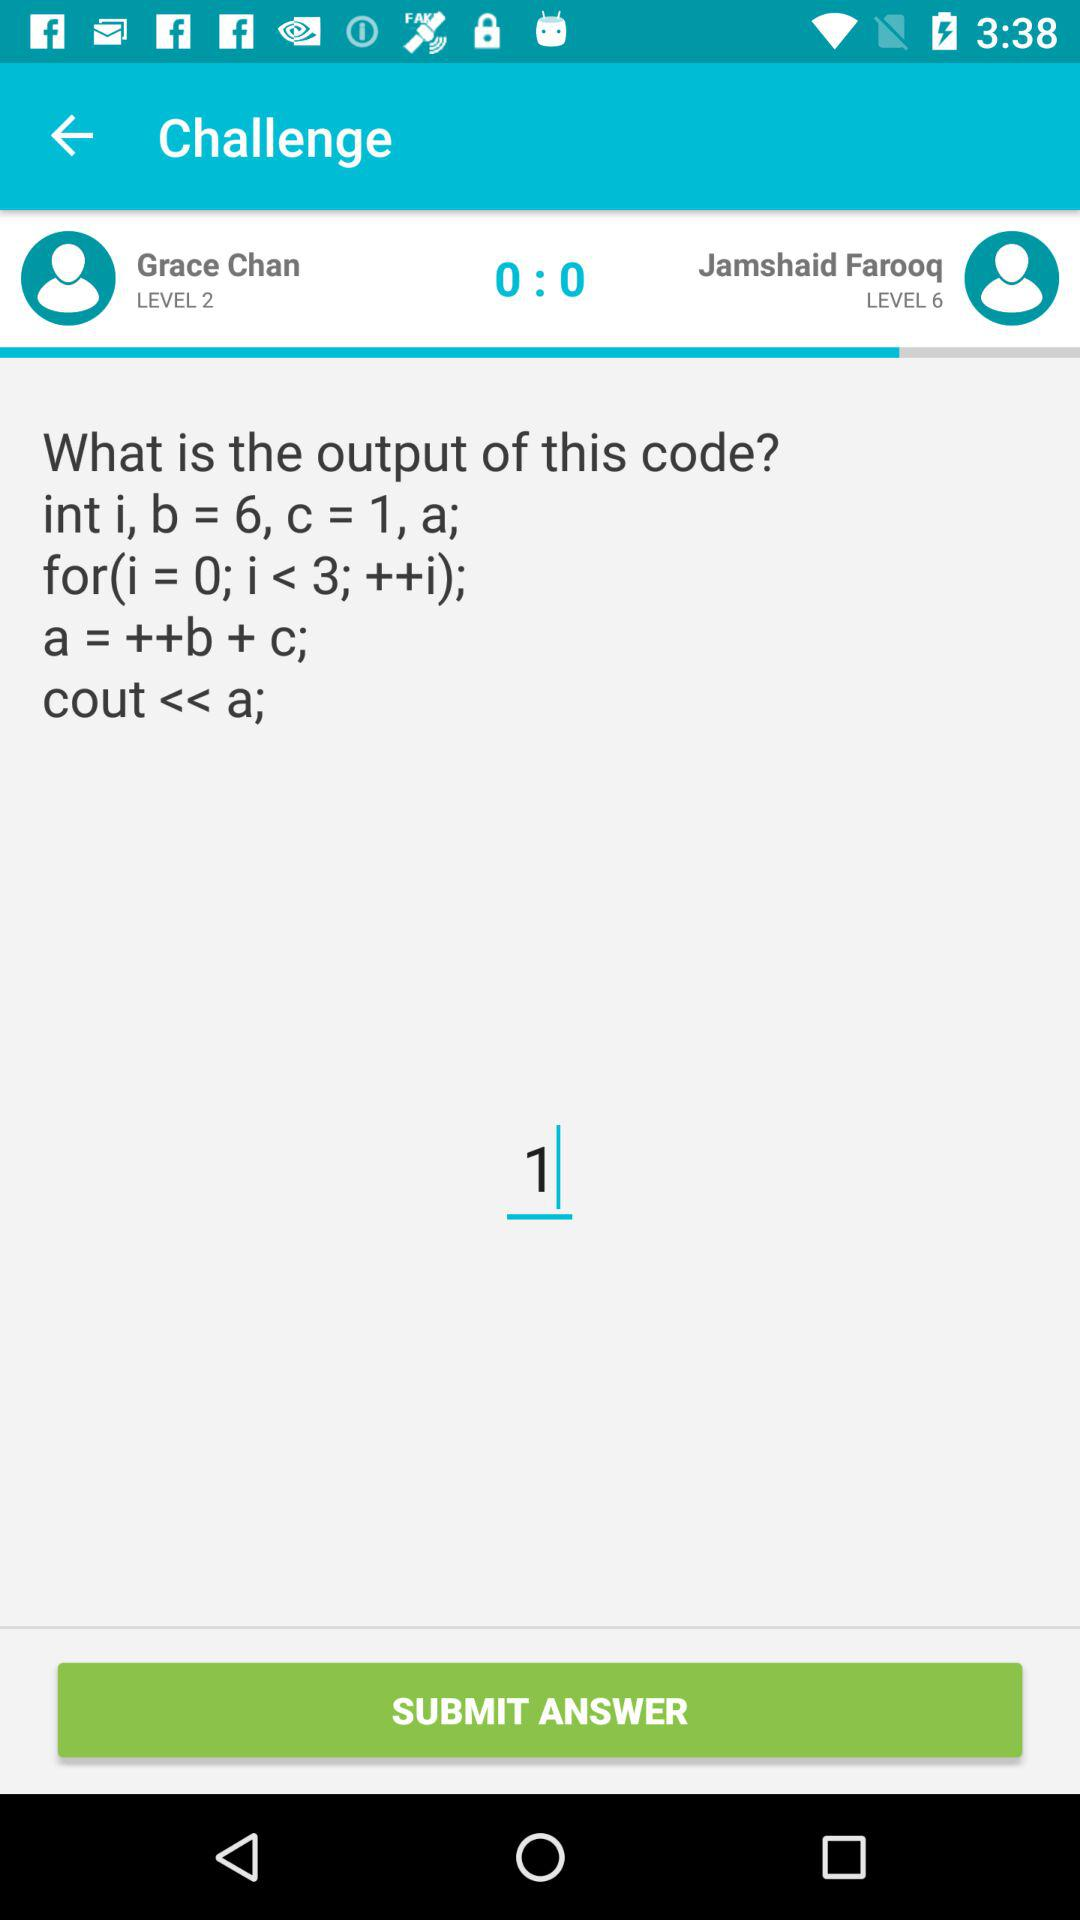What is the sum of the level of Grace Chan and Jamshaid Farooq?
Answer the question using a single word or phrase. 8 